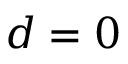Convert formula to latex. <formula><loc_0><loc_0><loc_500><loc_500>d = 0</formula> 